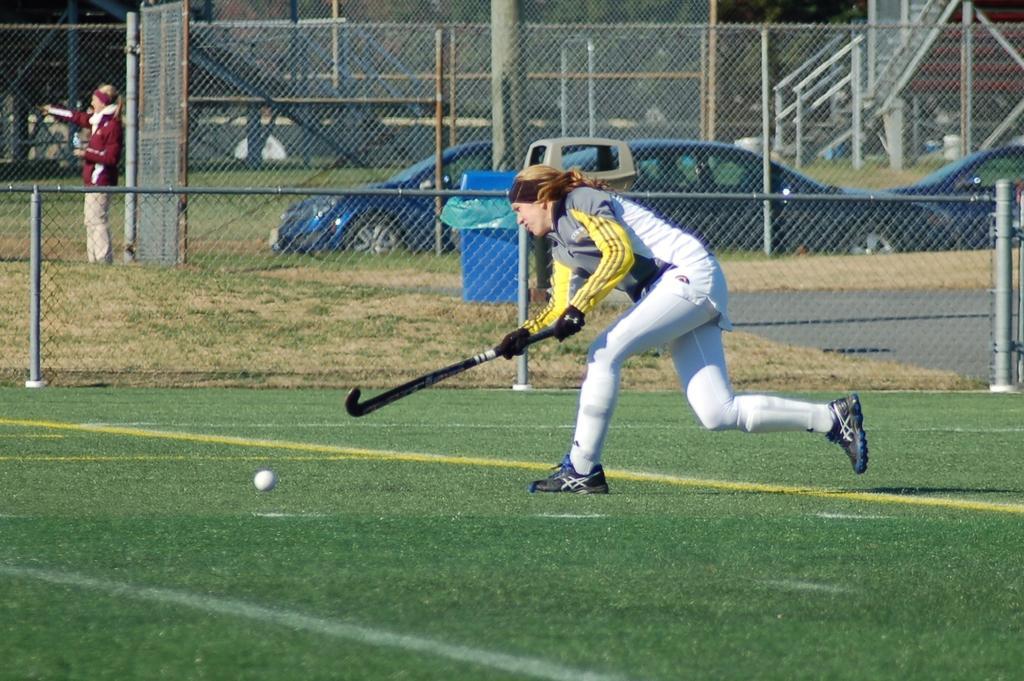Please provide a concise description of this image. In this image there is a lady playing on the ground with a hockey stick, behind her there is a net fence and there is a lady standing. In the background there are few cars parked. 